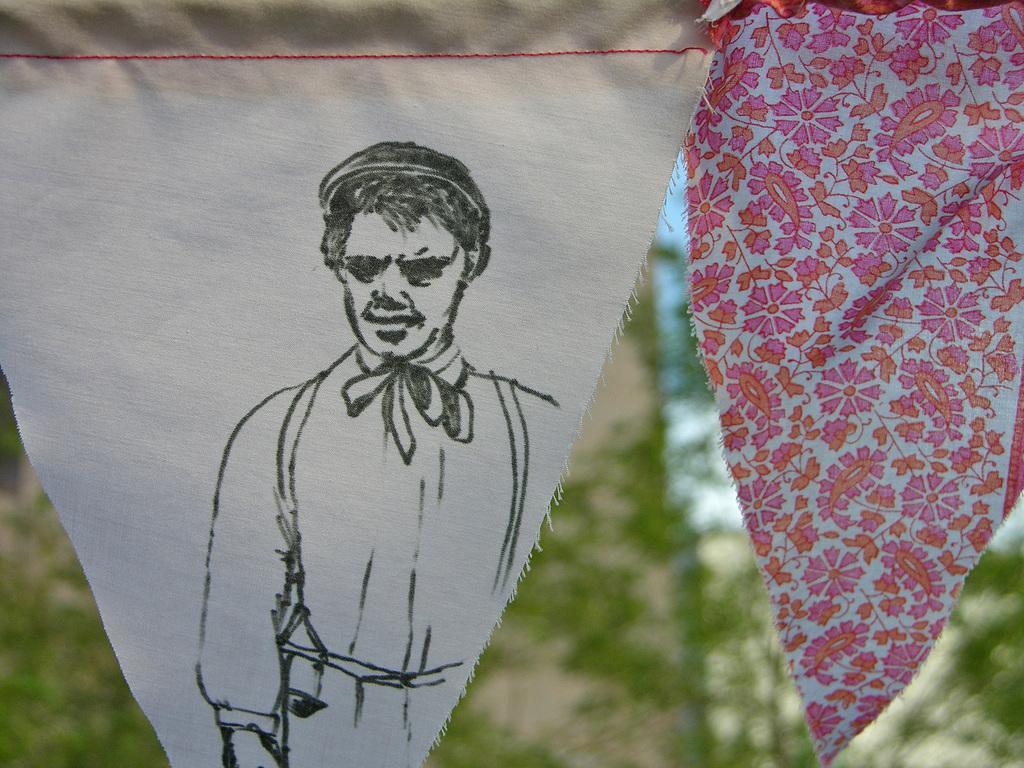In one or two sentences, can you explain what this image depicts? In this image we can see two clothes hanging at the top of the image, one man´s image printed on the white cloth, some trees in the background, it looks like a wall in the background, in the background there is the sky on the right side of the image and the background is blurred. 